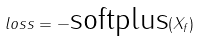Convert formula to latex. <formula><loc_0><loc_0><loc_500><loc_500>l o s s = - \text {softplus} ( X _ { f } )</formula> 